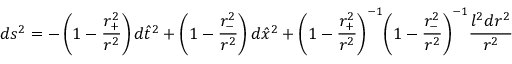<formula> <loc_0><loc_0><loc_500><loc_500>d s ^ { 2 } = - \left ( 1 - \frac { r _ { + } ^ { 2 } } { r ^ { 2 } } \right ) d { \hat { t } } ^ { 2 } + \left ( 1 - \frac { r _ { - } ^ { 2 } } { r ^ { 2 } } \right ) d { \hat { x } } ^ { 2 } + { \left ( 1 - \frac { r _ { + } ^ { 2 } } { r ^ { 2 } } \right ) } ^ { - 1 } { \left ( 1 - \frac { r _ { - } ^ { 2 } } { r ^ { 2 } } \right ) } ^ { - 1 } \frac { l ^ { 2 } d r ^ { 2 } } { r ^ { 2 } }</formula> 